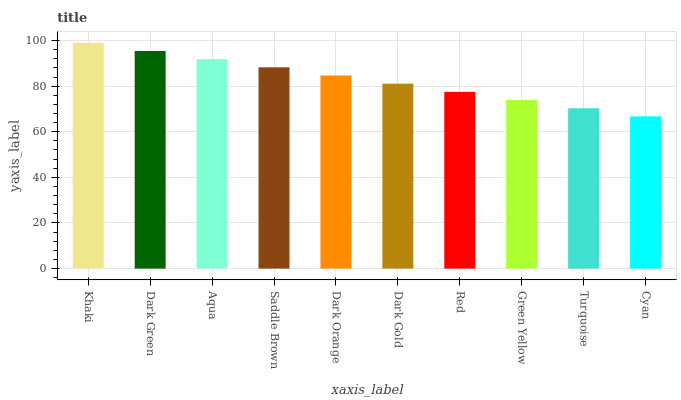Is Dark Green the minimum?
Answer yes or no. No. Is Dark Green the maximum?
Answer yes or no. No. Is Khaki greater than Dark Green?
Answer yes or no. Yes. Is Dark Green less than Khaki?
Answer yes or no. Yes. Is Dark Green greater than Khaki?
Answer yes or no. No. Is Khaki less than Dark Green?
Answer yes or no. No. Is Dark Orange the high median?
Answer yes or no. Yes. Is Dark Gold the low median?
Answer yes or no. Yes. Is Red the high median?
Answer yes or no. No. Is Cyan the low median?
Answer yes or no. No. 